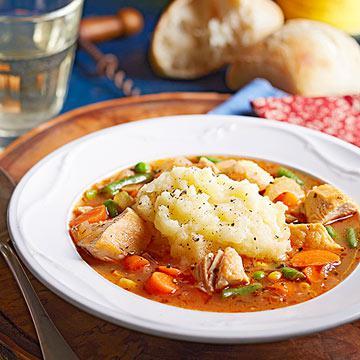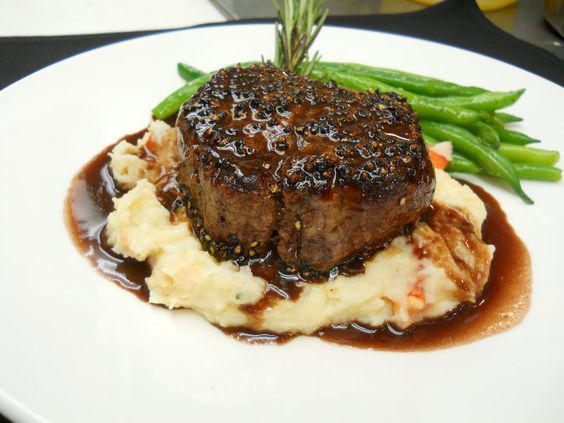The first image is the image on the left, the second image is the image on the right. Evaluate the accuracy of this statement regarding the images: "A fork is sitting on the right side of the plate in the image on the right.". Is it true? Answer yes or no. No. The first image is the image on the left, the second image is the image on the right. Assess this claim about the two images: "A fork is on the edge of a flower-patterned plate containing beef and gravy garnished with green sprigs.". Correct or not? Answer yes or no. No. 